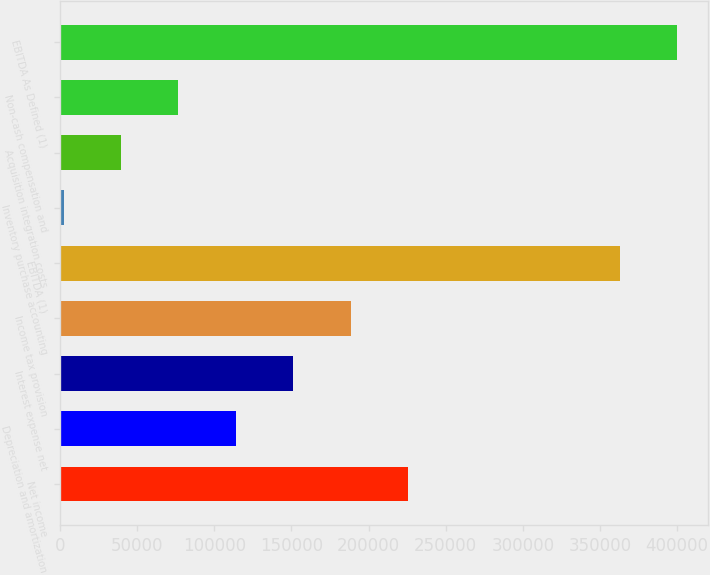Convert chart. <chart><loc_0><loc_0><loc_500><loc_500><bar_chart><fcel>Net income<fcel>Depreciation and amortization<fcel>Interest expense net<fcel>Income tax provision<fcel>EBITDA (1)<fcel>Inventory purchase accounting<fcel>Acquisition integration costs<fcel>Non-cash compensation and<fcel>EBITDA As Defined (1)<nl><fcel>225720<fcel>113992<fcel>151234<fcel>188477<fcel>362921<fcel>2264<fcel>39506.6<fcel>76749.2<fcel>400164<nl></chart> 